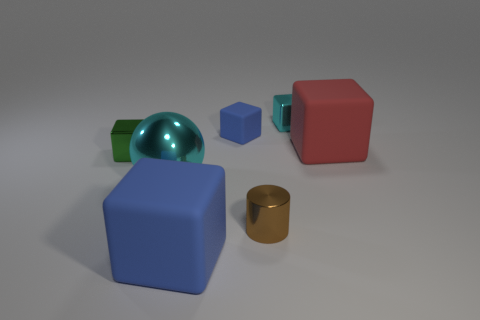Subtract all tiny cyan blocks. How many blocks are left? 4 Subtract all purple cubes. Subtract all brown cylinders. How many cubes are left? 5 Add 2 big yellow metal cubes. How many objects exist? 9 Subtract all cylinders. How many objects are left? 6 Add 4 brown things. How many brown things exist? 5 Subtract 1 cyan blocks. How many objects are left? 6 Subtract all blue matte cubes. Subtract all large blue blocks. How many objects are left? 4 Add 7 green metallic blocks. How many green metallic blocks are left? 8 